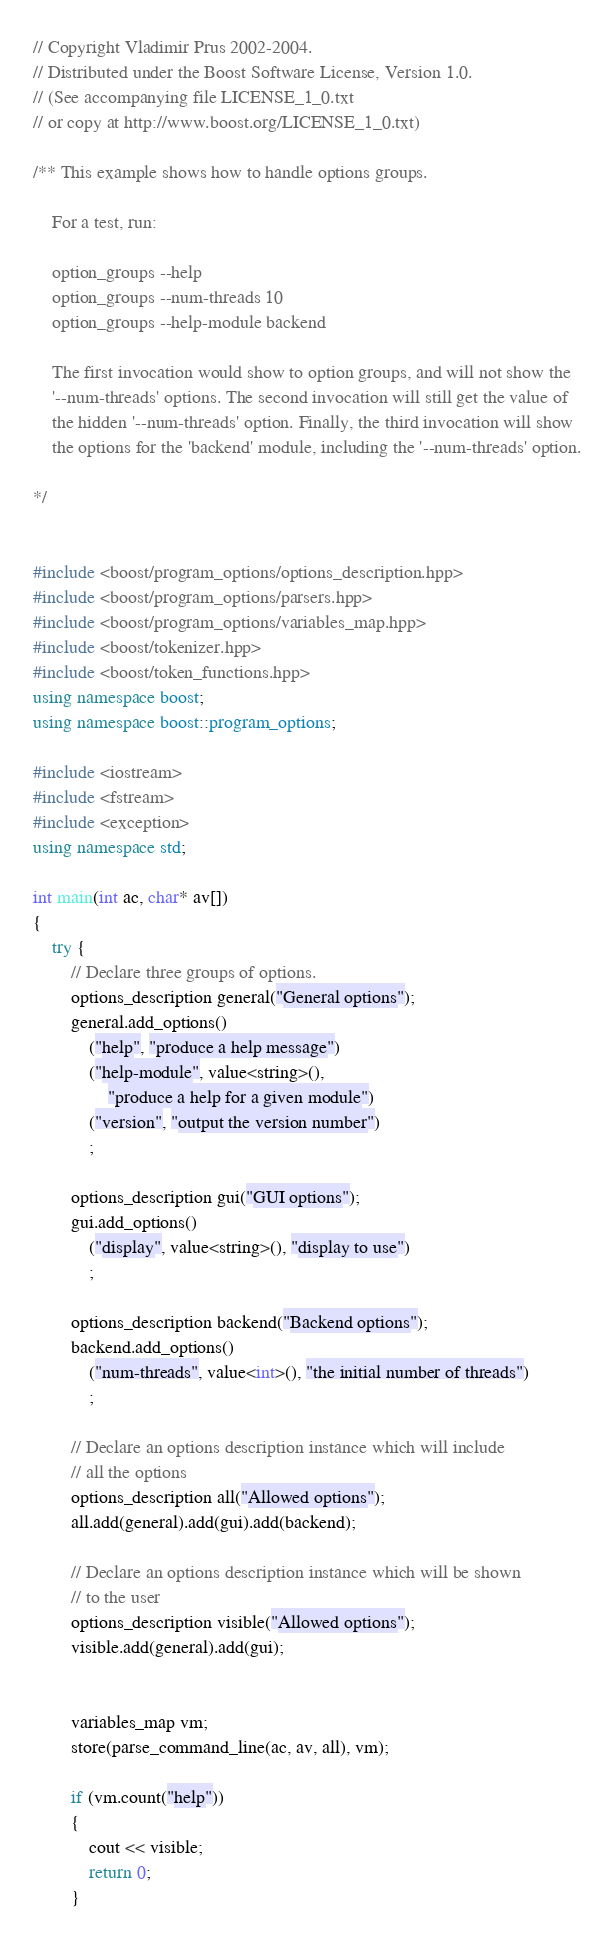<code> <loc_0><loc_0><loc_500><loc_500><_C++_>// Copyright Vladimir Prus 2002-2004.
// Distributed under the Boost Software License, Version 1.0.
// (See accompanying file LICENSE_1_0.txt
// or copy at http://www.boost.org/LICENSE_1_0.txt)

/** This example shows how to handle options groups.

    For a test, run:

    option_groups --help
    option_groups --num-threads 10
    option_groups --help-module backend

    The first invocation would show to option groups, and will not show the
    '--num-threads' options. The second invocation will still get the value of
    the hidden '--num-threads' option. Finally, the third invocation will show
    the options for the 'backend' module, including the '--num-threads' option.

*/


#include <boost/program_options/options_description.hpp>
#include <boost/program_options/parsers.hpp>
#include <boost/program_options/variables_map.hpp>
#include <boost/tokenizer.hpp>
#include <boost/token_functions.hpp>
using namespace boost;
using namespace boost::program_options;

#include <iostream>
#include <fstream>
#include <exception>
using namespace std;

int main(int ac, char* av[])
{
    try {
        // Declare three groups of options.
        options_description general("General options");
        general.add_options()
            ("help", "produce a help message")
            ("help-module", value<string>(),
                "produce a help for a given module")
            ("version", "output the version number")
            ;

        options_description gui("GUI options");
        gui.add_options()
            ("display", value<string>(), "display to use")
            ;

        options_description backend("Backend options");
        backend.add_options()
            ("num-threads", value<int>(), "the initial number of threads")
            ;
            
        // Declare an options description instance which will include
        // all the options
        options_description all("Allowed options");
        all.add(general).add(gui).add(backend);

        // Declare an options description instance which will be shown
        // to the user
        options_description visible("Allowed options");
        visible.add(general).add(gui);
           

        variables_map vm;
        store(parse_command_line(ac, av, all), vm);

        if (vm.count("help")) 
        {
            cout << visible;
            return 0;
        }</code> 